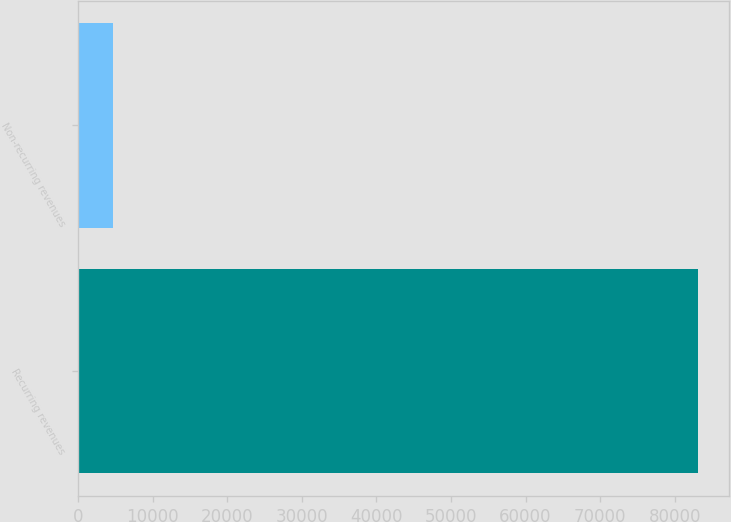Convert chart. <chart><loc_0><loc_0><loc_500><loc_500><bar_chart><fcel>Recurring revenues<fcel>Non-recurring revenues<nl><fcel>83080<fcel>4646<nl></chart> 